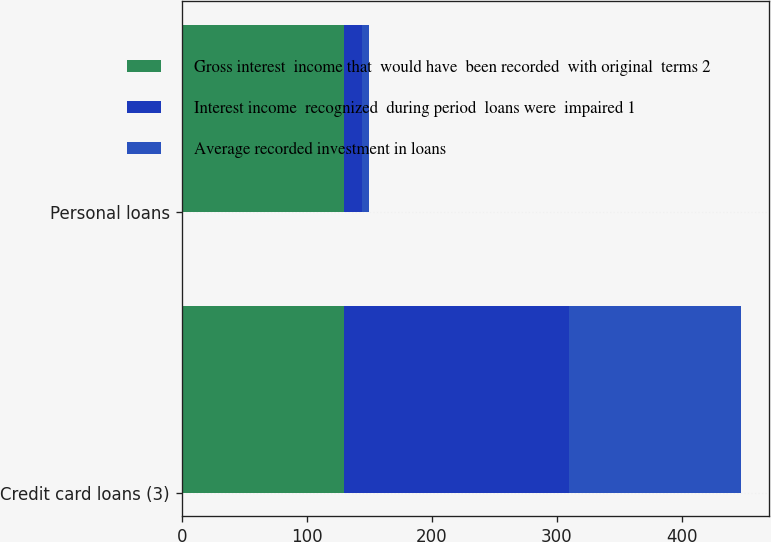Convert chart. <chart><loc_0><loc_0><loc_500><loc_500><stacked_bar_chart><ecel><fcel>Credit card loans (3)<fcel>Personal loans<nl><fcel>Gross interest  income that  would have  been recorded  with original  terms 2<fcel>130<fcel>130<nl><fcel>Interest income  recognized  during period  loans were  impaired 1<fcel>180<fcel>14<nl><fcel>Average recorded investment in loans<fcel>137<fcel>6<nl></chart> 